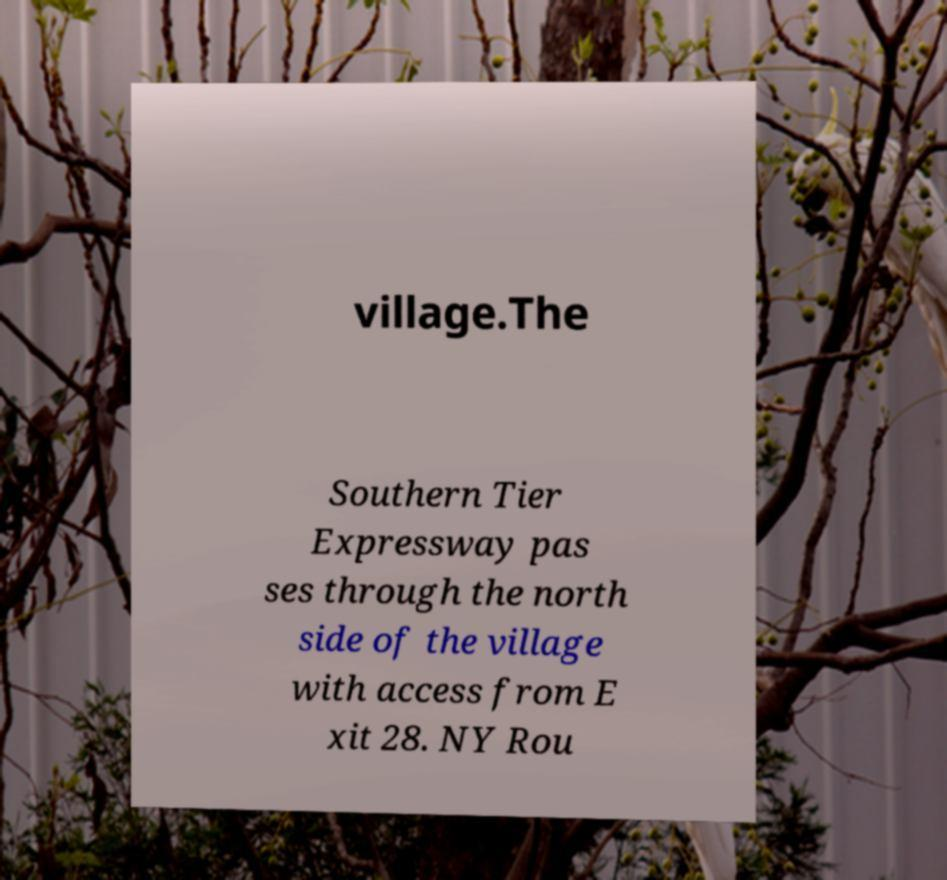Please read and relay the text visible in this image. What does it say? village.The Southern Tier Expressway pas ses through the north side of the village with access from E xit 28. NY Rou 